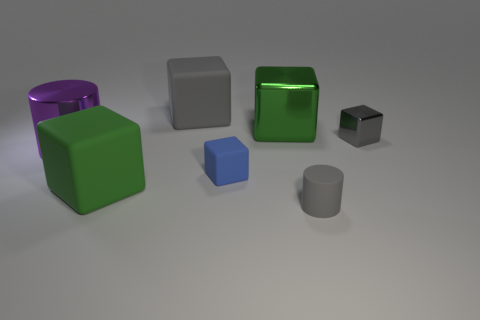There is a tiny matte cylinder; is its color the same as the large matte block that is behind the green rubber cube?
Offer a very short reply. Yes. Is the color of the tiny cube behind the purple cylinder the same as the small matte cylinder?
Keep it short and to the point. Yes. What material is the cylinder that is the same color as the small shiny cube?
Your response must be concise. Rubber. What number of cylinders have the same color as the small shiny object?
Ensure brevity in your answer.  1. What size is the matte block that is the same color as the tiny cylinder?
Provide a succinct answer. Large. Does the green object that is behind the gray metal thing have the same size as the rubber object that is behind the tiny gray cube?
Your response must be concise. Yes. How many other objects are the same shape as the large purple thing?
Your answer should be very brief. 1. What material is the small gray object that is behind the cylinder on the right side of the big purple object?
Provide a succinct answer. Metal. What number of shiny things are either big gray objects or big green things?
Provide a succinct answer. 1. There is a big metal block that is on the left side of the tiny matte cylinder; are there any tiny matte things that are to the left of it?
Your response must be concise. Yes. 